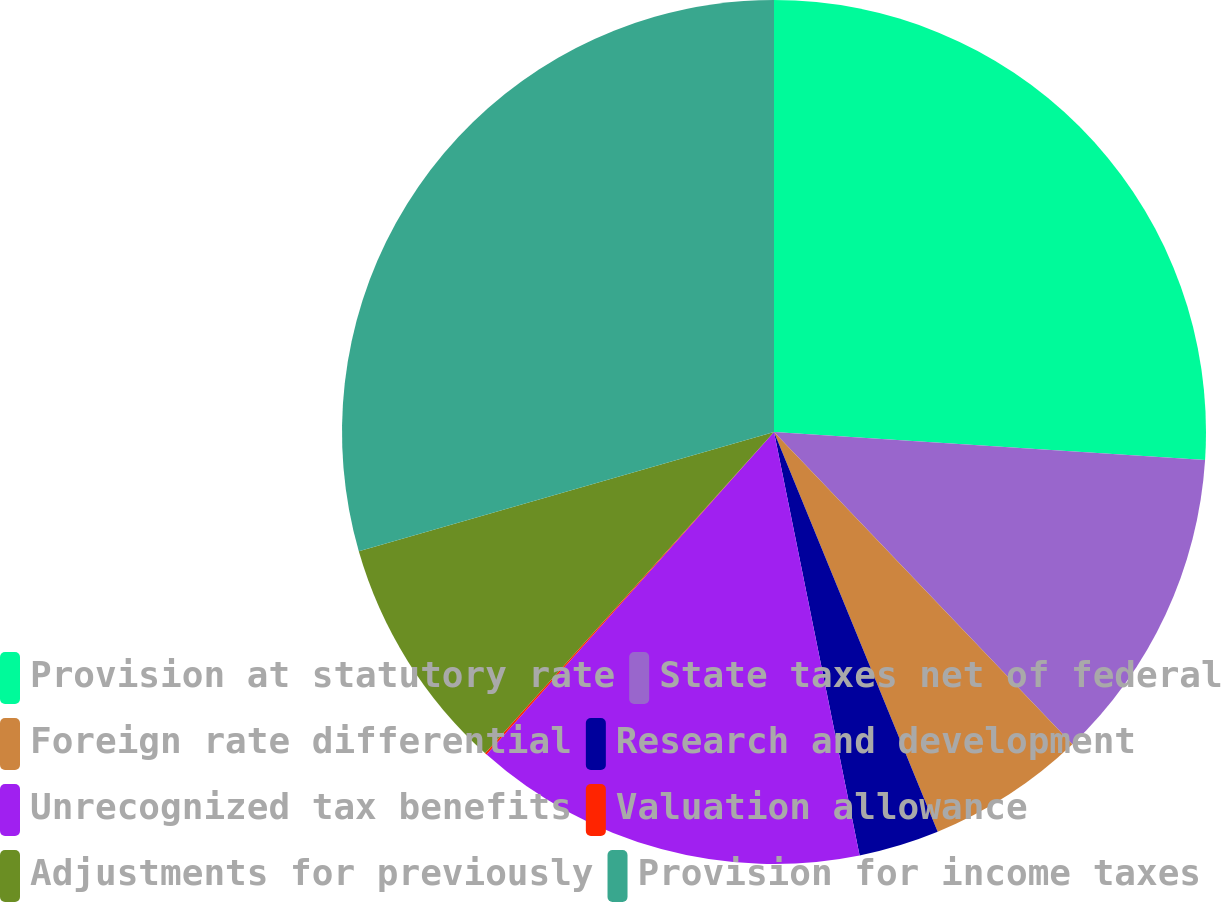Convert chart. <chart><loc_0><loc_0><loc_500><loc_500><pie_chart><fcel>Provision at statutory rate<fcel>State taxes net of federal<fcel>Foreign rate differential<fcel>Research and development<fcel>Unrecognized tax benefits<fcel>Valuation allowance<fcel>Adjustments for previously<fcel>Provision for income taxes<nl><fcel>26.03%<fcel>11.83%<fcel>5.95%<fcel>3.01%<fcel>14.76%<fcel>0.07%<fcel>8.89%<fcel>29.45%<nl></chart> 